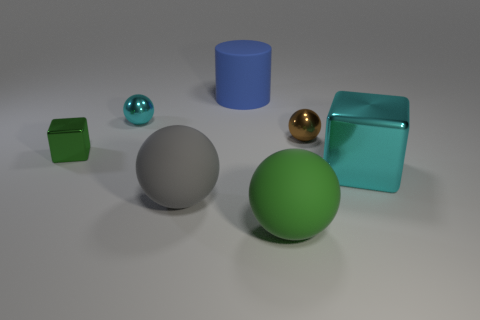Subtract all cyan metal spheres. How many spheres are left? 3 Add 1 tiny green metallic blocks. How many objects exist? 8 Subtract 4 balls. How many balls are left? 0 Subtract all green blocks. How many blocks are left? 1 Subtract 0 gray cylinders. How many objects are left? 7 Subtract all cubes. How many objects are left? 5 Subtract all brown cubes. Subtract all yellow cylinders. How many cubes are left? 2 Subtract all purple cylinders. How many cyan blocks are left? 1 Subtract all balls. Subtract all tiny brown shiny objects. How many objects are left? 2 Add 7 small spheres. How many small spheres are left? 9 